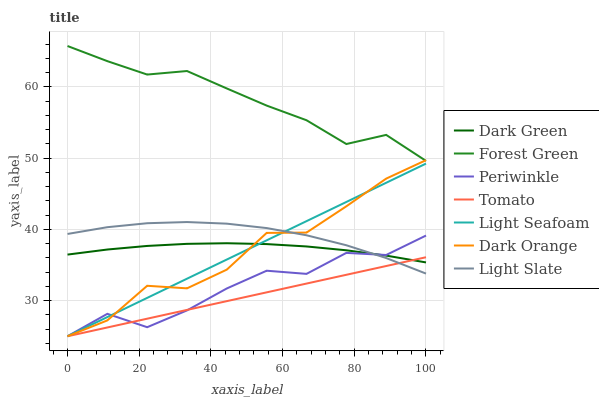Does Tomato have the minimum area under the curve?
Answer yes or no. Yes. Does Forest Green have the maximum area under the curve?
Answer yes or no. Yes. Does Dark Orange have the minimum area under the curve?
Answer yes or no. No. Does Dark Orange have the maximum area under the curve?
Answer yes or no. No. Is Tomato the smoothest?
Answer yes or no. Yes. Is Dark Orange the roughest?
Answer yes or no. Yes. Is Light Slate the smoothest?
Answer yes or no. No. Is Light Slate the roughest?
Answer yes or no. No. Does Tomato have the lowest value?
Answer yes or no. Yes. Does Light Slate have the lowest value?
Answer yes or no. No. Does Forest Green have the highest value?
Answer yes or no. Yes. Does Dark Orange have the highest value?
Answer yes or no. No. Is Light Seafoam less than Forest Green?
Answer yes or no. Yes. Is Forest Green greater than Light Slate?
Answer yes or no. Yes. Does Dark Orange intersect Light Slate?
Answer yes or no. Yes. Is Dark Orange less than Light Slate?
Answer yes or no. No. Is Dark Orange greater than Light Slate?
Answer yes or no. No. Does Light Seafoam intersect Forest Green?
Answer yes or no. No. 